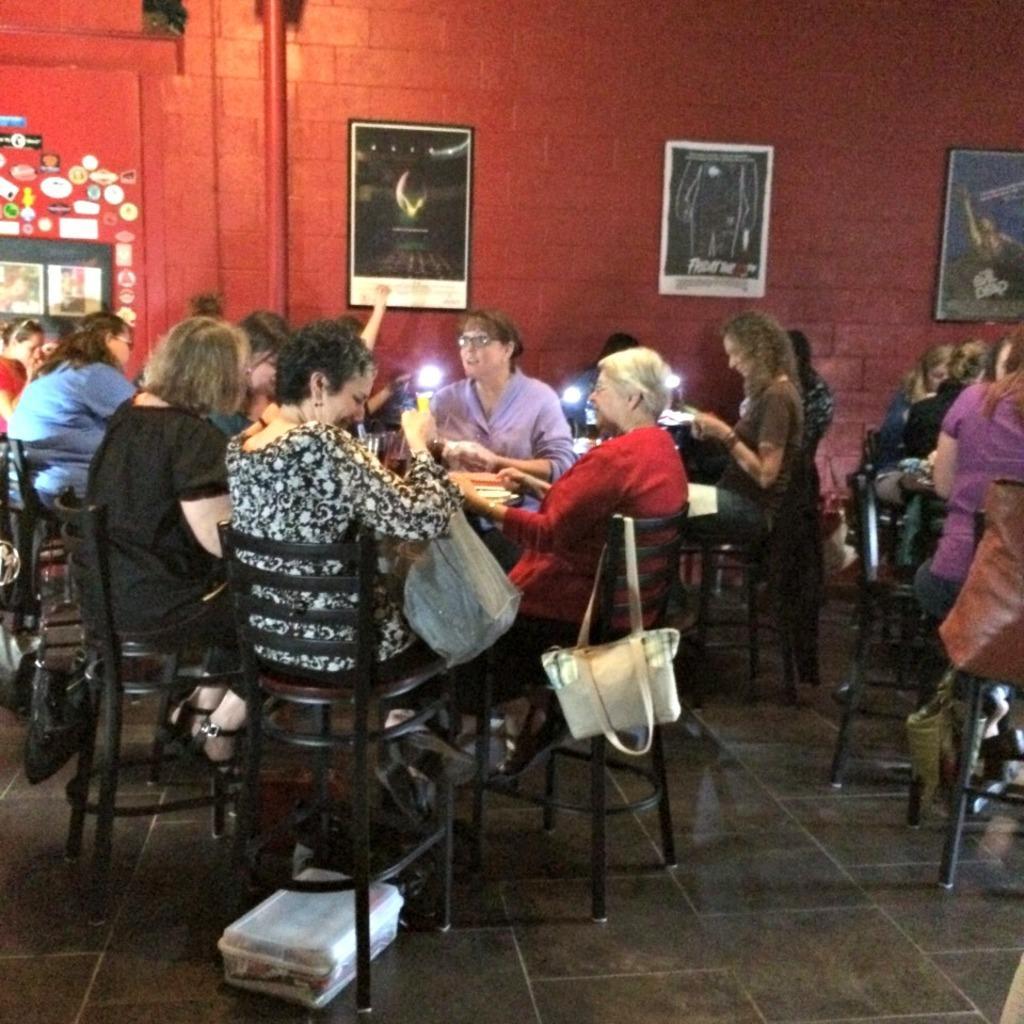Can you describe this image briefly? people are sitting. white bag is hanging on the chair. behind them there is a red wall on which photo frames are hung. 